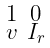Convert formula to latex. <formula><loc_0><loc_0><loc_500><loc_500>\begin{smallmatrix} 1 & 0 \\ v & I _ { r } \end{smallmatrix}</formula> 